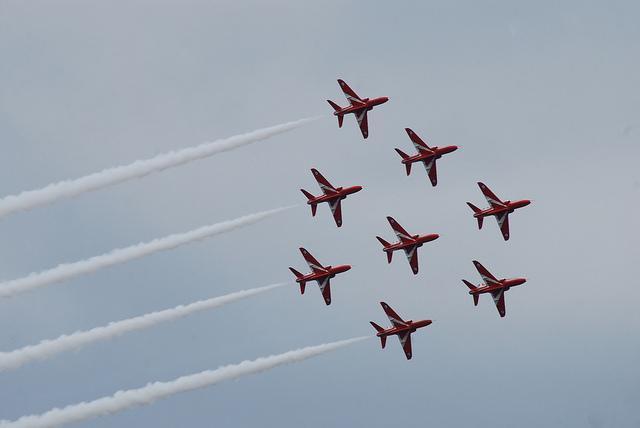How many planes are there?
Give a very brief answer. 8. How many airplanes are there?
Give a very brief answer. 8. How many woman are holding a donut with one hand?
Give a very brief answer. 0. 